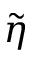Convert formula to latex. <formula><loc_0><loc_0><loc_500><loc_500>\widetilde { \eta }</formula> 